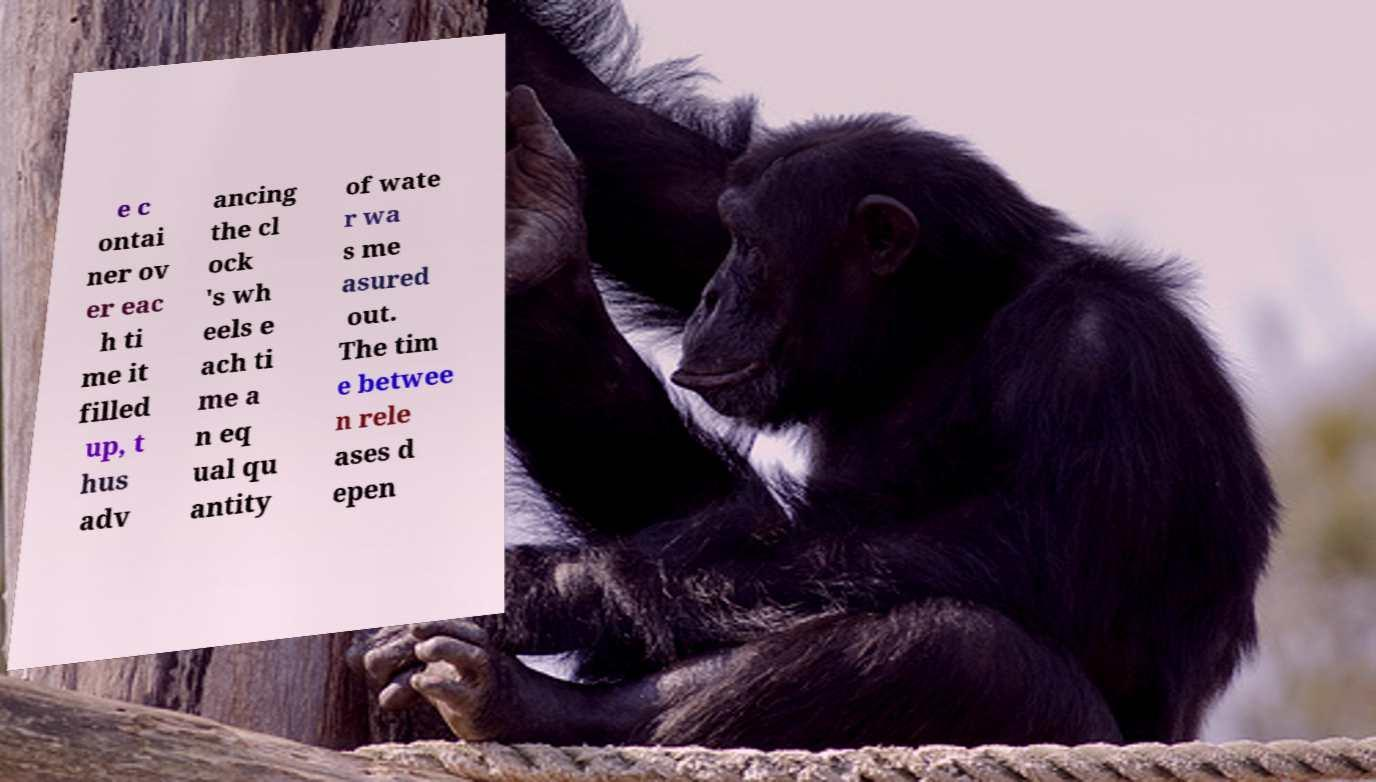There's text embedded in this image that I need extracted. Can you transcribe it verbatim? e c ontai ner ov er eac h ti me it filled up, t hus adv ancing the cl ock 's wh eels e ach ti me a n eq ual qu antity of wate r wa s me asured out. The tim e betwee n rele ases d epen 